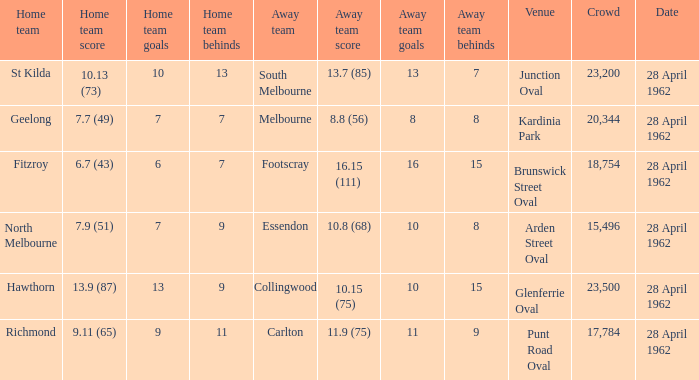At what venue did an away team score 10.15 (75)? Glenferrie Oval. Parse the full table. {'header': ['Home team', 'Home team score', 'Home team goals', 'Home team behinds', 'Away team', 'Away team score', 'Away team goals', 'Away team behinds', 'Venue', 'Crowd', 'Date'], 'rows': [['St Kilda', '10.13 (73)', '10', '13', 'South Melbourne', '13.7 (85)', '13', '7', 'Junction Oval', '23,200', '28 April 1962'], ['Geelong', '7.7 (49)', '7', '7', 'Melbourne', '8.8 (56)', '8', '8', 'Kardinia Park', '20,344', '28 April 1962'], ['Fitzroy', '6.7 (43)', '6', '7', 'Footscray', '16.15 (111)', '16', '15', 'Brunswick Street Oval', '18,754', '28 April 1962'], ['North Melbourne', '7.9 (51)', '7', '9', 'Essendon', '10.8 (68)', '10', '8', 'Arden Street Oval', '15,496', '28 April 1962'], ['Hawthorn', '13.9 (87)', '13', '9', 'Collingwood', '10.15 (75)', '10', '15', 'Glenferrie Oval', '23,500', '28 April 1962'], ['Richmond', '9.11 (65)', '9', '11', 'Carlton', '11.9 (75)', '11', '9', 'Punt Road Oval', '17,784', '28 April 1962']]} 